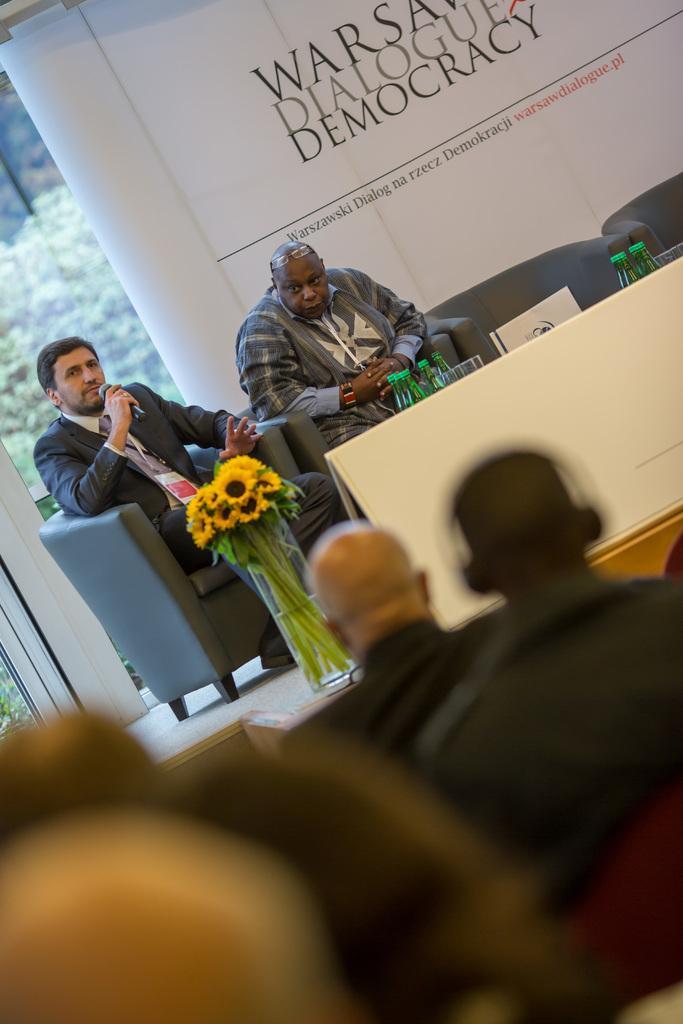Please provide a concise description of this image. In this picture I can see there are two people sitting on the couch and there is a table in front of them, they are sitting on the dais, there is a flower pot on the table and there is a banner in the backdrop, there are few bottles, a laptop and glasses. There is a banner in the backdrop. 